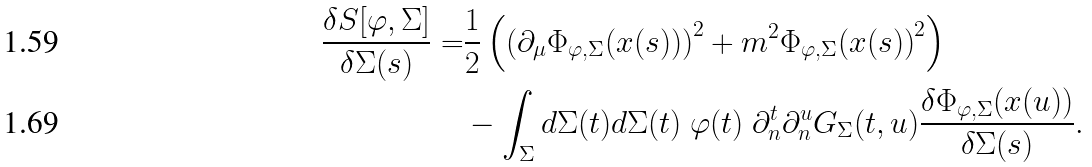Convert formula to latex. <formula><loc_0><loc_0><loc_500><loc_500>\frac { \delta S [ \varphi , \Sigma ] } { \delta \Sigma ( s ) } = & \frac { 1 } { 2 } \left ( \left ( \partial _ { \mu } { \Phi _ { \varphi , \Sigma } ( x ( s ) ) } \right ) ^ { 2 } + m ^ { 2 } { \Phi _ { \varphi , \Sigma } ( x ( s ) ) } ^ { 2 } \right ) \\ & - \int _ { \Sigma } d \Sigma ( t ) d \Sigma ( t ) \ \varphi ( t ) \ \partial _ { n } ^ { t } \partial _ { n } ^ { u } G _ { \Sigma } ( t , u ) \frac { \delta { \Phi _ { \varphi , \Sigma } } ( x ( u ) ) } { \delta \Sigma ( s ) } .</formula> 